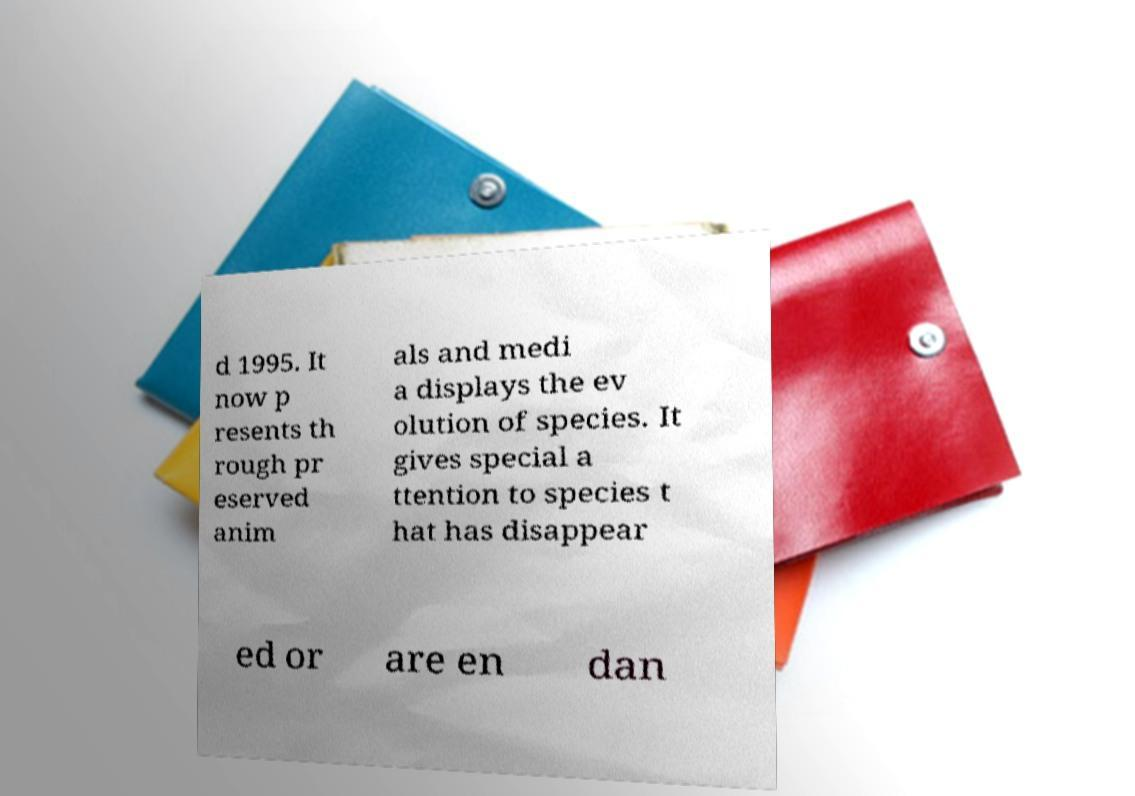Please identify and transcribe the text found in this image. d 1995. It now p resents th rough pr eserved anim als and medi a displays the ev olution of species. It gives special a ttention to species t hat has disappear ed or are en dan 